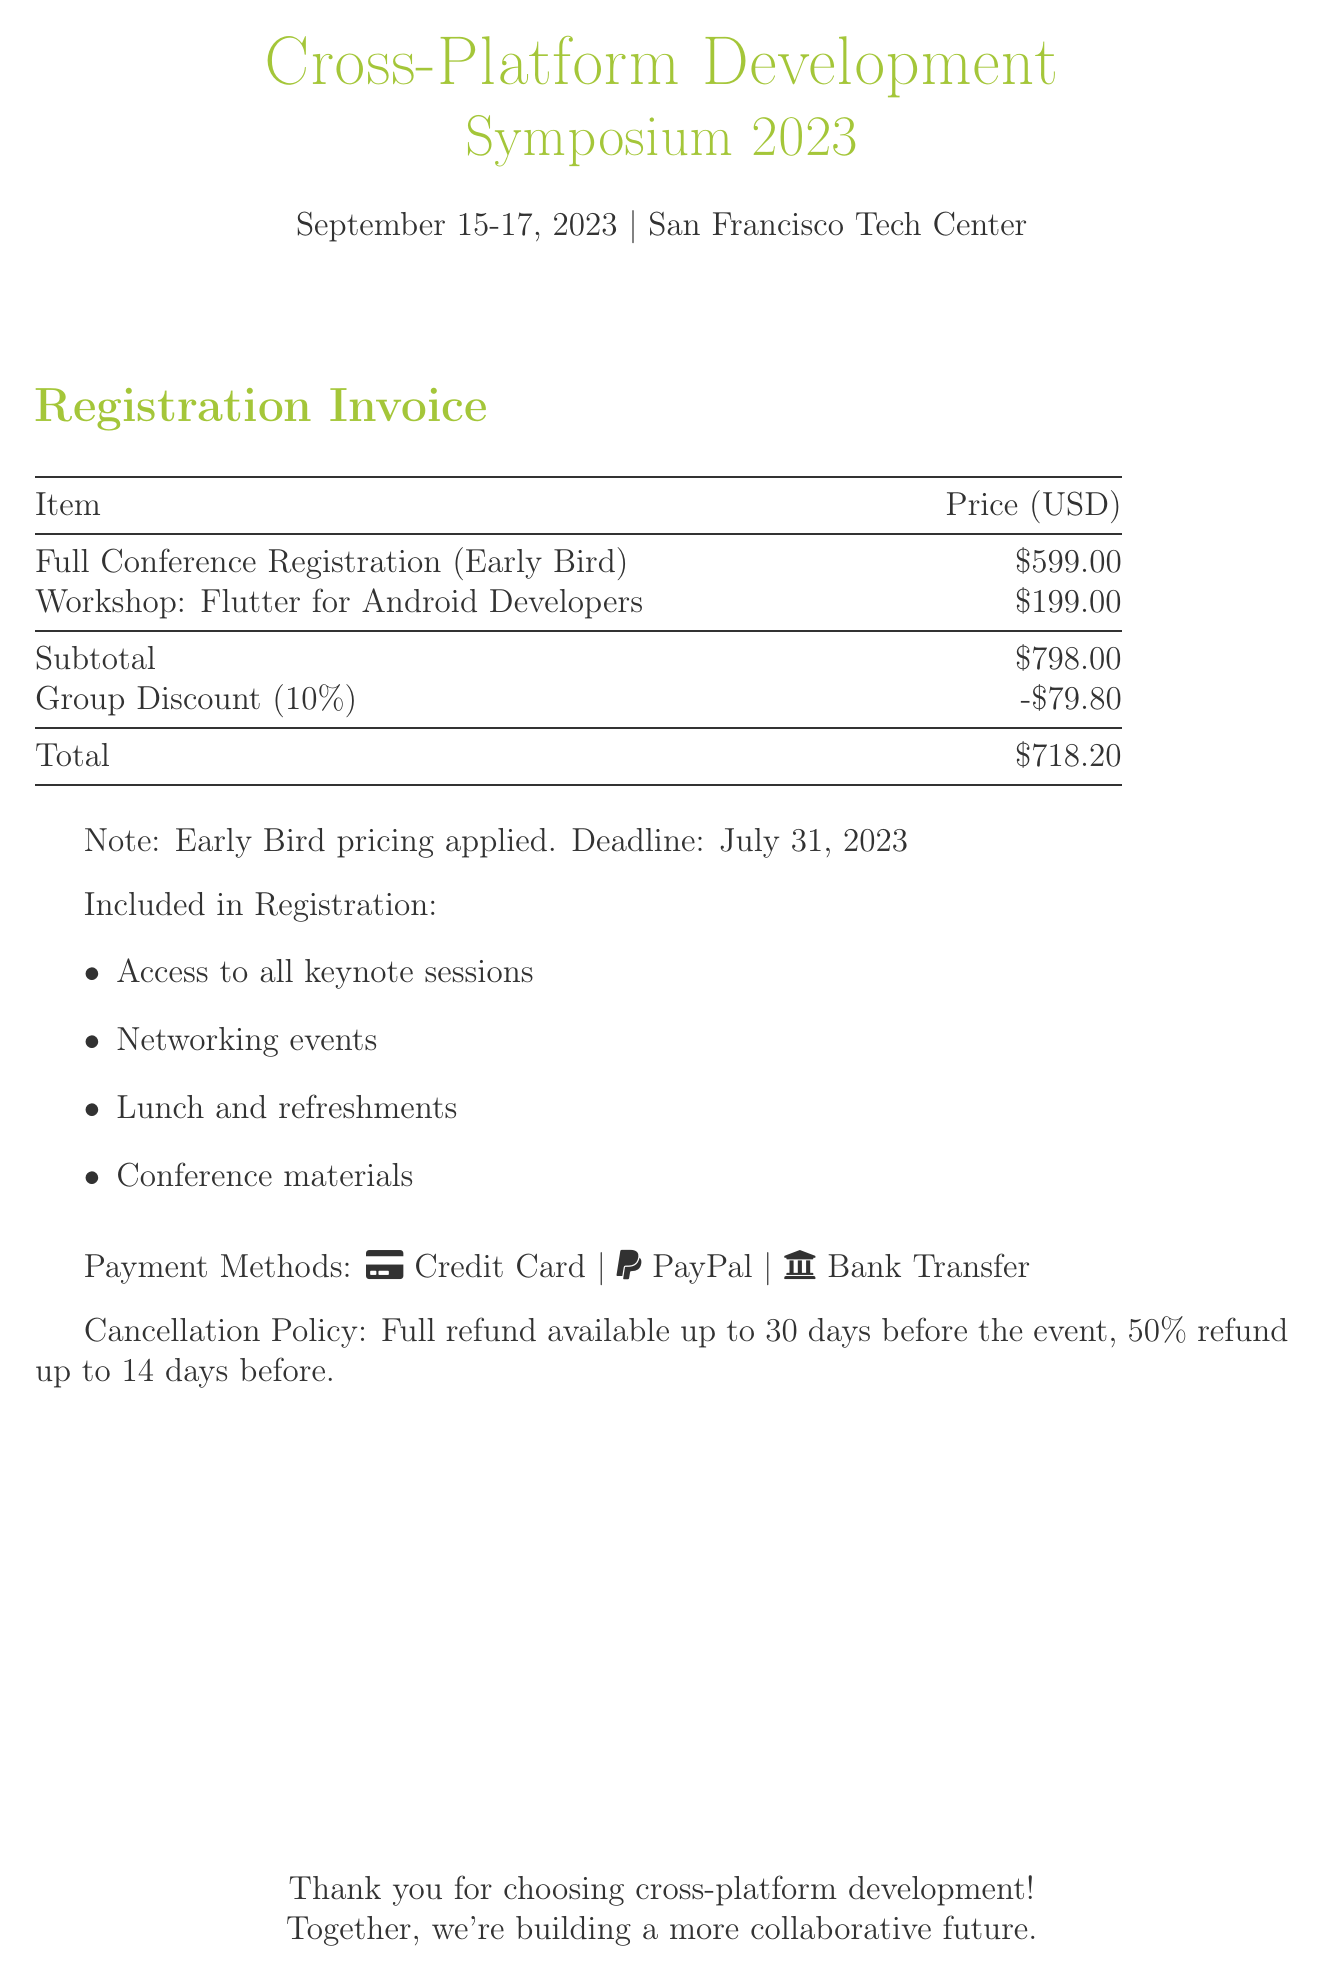What is the date of the symposium? The document states that the symposium will take place from September 15-17, 2023.
Answer: September 15-17, 2023 What is the total registration fee after the discount? The total after applying the group discount to the subtotal is listed as $718.20.
Answer: $718.20 What is the early bird registration price? The early bird price for full conference registration is outlined as $599.00.
Answer: $599.00 What types of payment are accepted? The document lists credit card, PayPal, and bank transfer as accepted payment methods.
Answer: Credit Card, PayPal, Bank Transfer What is the group discount percentage? The document specifies a group discount of 10%.
Answer: 10% What is the price of the Flutter workshop? The workshop fee for "Flutter for Android Developers" is provided as $199.00.
Answer: $199.00 What is the cancellation policy for the event? The cancellation policy allows for a full refund up to 30 days and a 50% refund up to 14 days before the event.
Answer: Full refund up to 30 days; 50% refund up to 14 days What is included in the registration? The document lists several inclusions such as access to keynote sessions, networking events, lunch, refreshments, and conference materials.
Answer: Access to all keynote sessions, networking events, lunch and refreshments, conference materials 